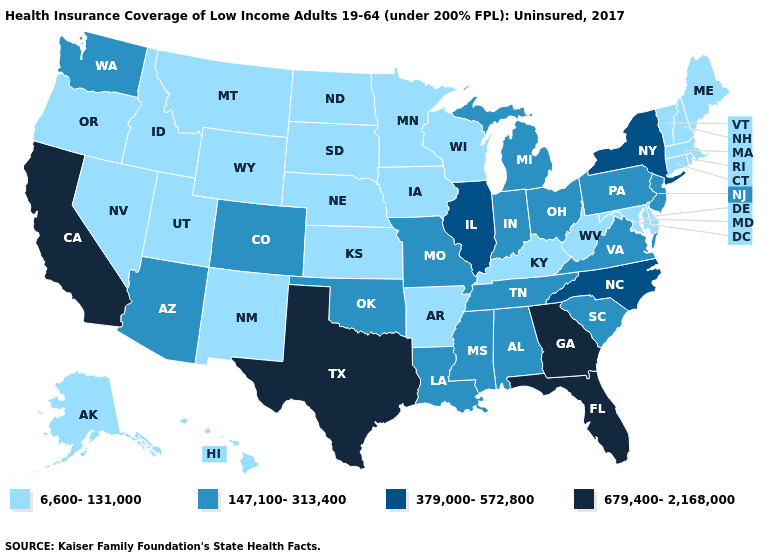What is the value of Delaware?
Write a very short answer. 6,600-131,000. Name the states that have a value in the range 679,400-2,168,000?
Quick response, please. California, Florida, Georgia, Texas. Does Alabama have a lower value than Montana?
Keep it brief. No. What is the highest value in the MidWest ?
Be succinct. 379,000-572,800. Does Kansas have a higher value than Missouri?
Write a very short answer. No. Name the states that have a value in the range 6,600-131,000?
Concise answer only. Alaska, Arkansas, Connecticut, Delaware, Hawaii, Idaho, Iowa, Kansas, Kentucky, Maine, Maryland, Massachusetts, Minnesota, Montana, Nebraska, Nevada, New Hampshire, New Mexico, North Dakota, Oregon, Rhode Island, South Dakota, Utah, Vermont, West Virginia, Wisconsin, Wyoming. What is the lowest value in the USA?
Keep it brief. 6,600-131,000. Name the states that have a value in the range 6,600-131,000?
Answer briefly. Alaska, Arkansas, Connecticut, Delaware, Hawaii, Idaho, Iowa, Kansas, Kentucky, Maine, Maryland, Massachusetts, Minnesota, Montana, Nebraska, Nevada, New Hampshire, New Mexico, North Dakota, Oregon, Rhode Island, South Dakota, Utah, Vermont, West Virginia, Wisconsin, Wyoming. Does Delaware have the highest value in the South?
Answer briefly. No. What is the lowest value in the MidWest?
Short answer required. 6,600-131,000. Name the states that have a value in the range 679,400-2,168,000?
Give a very brief answer. California, Florida, Georgia, Texas. Name the states that have a value in the range 379,000-572,800?
Be succinct. Illinois, New York, North Carolina. Does New Mexico have a lower value than Arkansas?
Answer briefly. No. Among the states that border Wisconsin , which have the lowest value?
Write a very short answer. Iowa, Minnesota. 